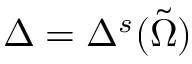<formula> <loc_0><loc_0><loc_500><loc_500>\Delta = \Delta ^ { s } ( \tilde { \Omega } )</formula> 